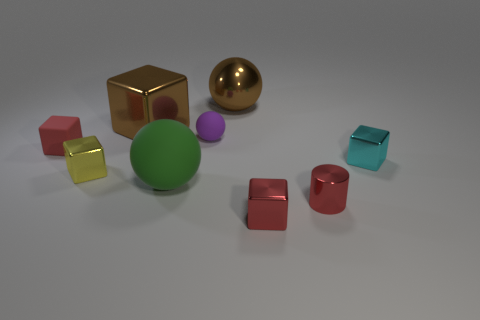How many big brown metallic things are the same shape as the large green object?
Provide a succinct answer. 1. Do the red object that is left of the tiny purple ball and the cyan metal object behind the cylinder have the same size?
Your response must be concise. Yes. What is the shape of the red object that is left of the metallic block on the left side of the brown block?
Provide a succinct answer. Cube. Are there the same number of purple rubber objects that are behind the small purple thing and green balls?
Ensure brevity in your answer.  No. The big ball behind the rubber sphere behind the tiny red thing behind the cyan shiny block is made of what material?
Your answer should be compact. Metal. Is there a red matte block of the same size as the metallic ball?
Keep it short and to the point. No. What shape is the yellow metallic object?
Provide a succinct answer. Cube. How many spheres are large things or tiny red metal things?
Your response must be concise. 2. Are there the same number of small matte things that are in front of the purple rubber sphere and large brown metallic cubes in front of the tiny cyan shiny cube?
Keep it short and to the point. No. What number of spheres are on the left side of the small rubber thing that is right of the red object that is behind the small red cylinder?
Your response must be concise. 1. 